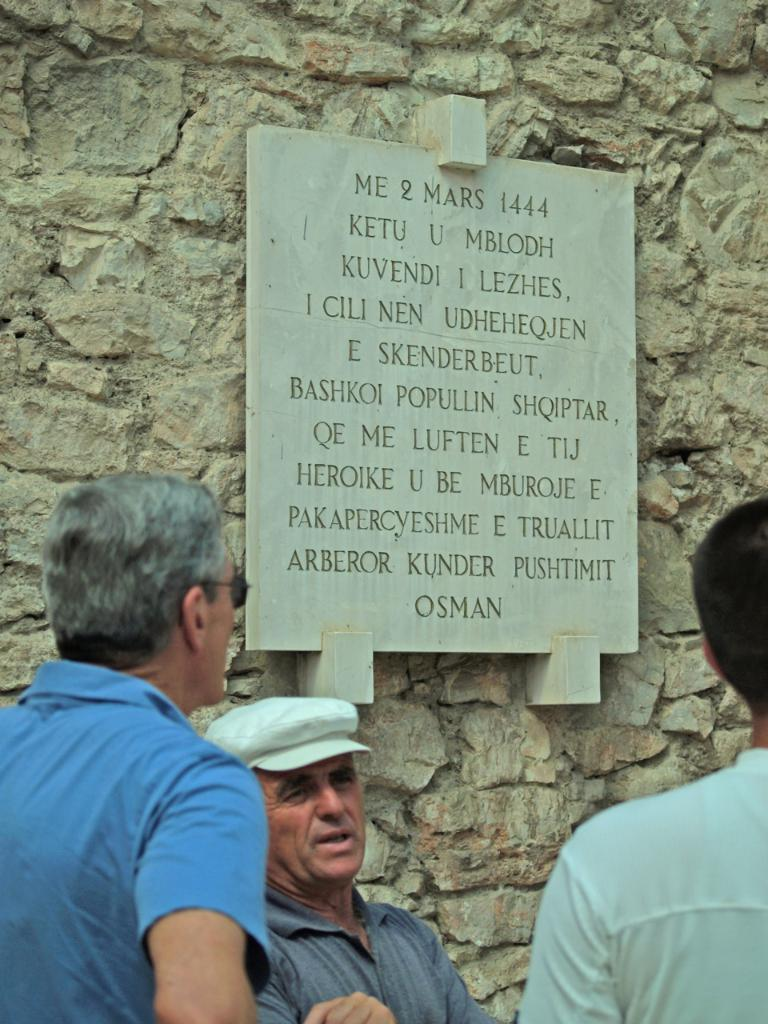Who or what can be seen in the front of the image? There are persons in the front of the image. What is visible in the background of the image? There is a wall in the background of the image. What is attached to the wall? There is a board hanging on the wall. What is written on the board? There is text written on the board. Can you tell me how many faucets are visible in the image? There are no faucets present in the image. What thoughts or ideas are being expressed by the persons in the image? The image does not provide any information about the thoughts or ideas of the persons; it only shows their physical presence. 